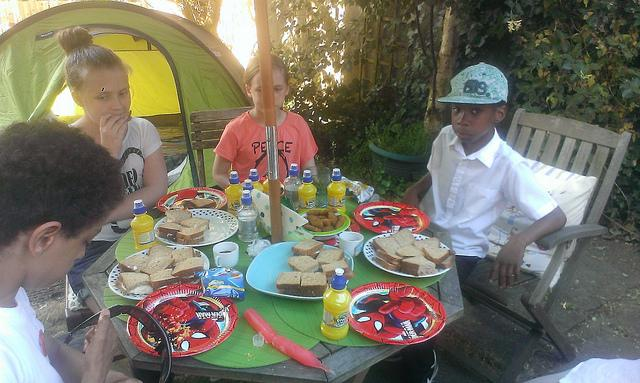What comic brand owns the franchise depicted here? marvel 